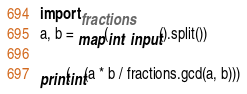Convert code to text. <code><loc_0><loc_0><loc_500><loc_500><_Python_>
import fractions
a, b = map(int, input().split())

print(int(a * b / fractions.gcd(a, b)))
</code> 